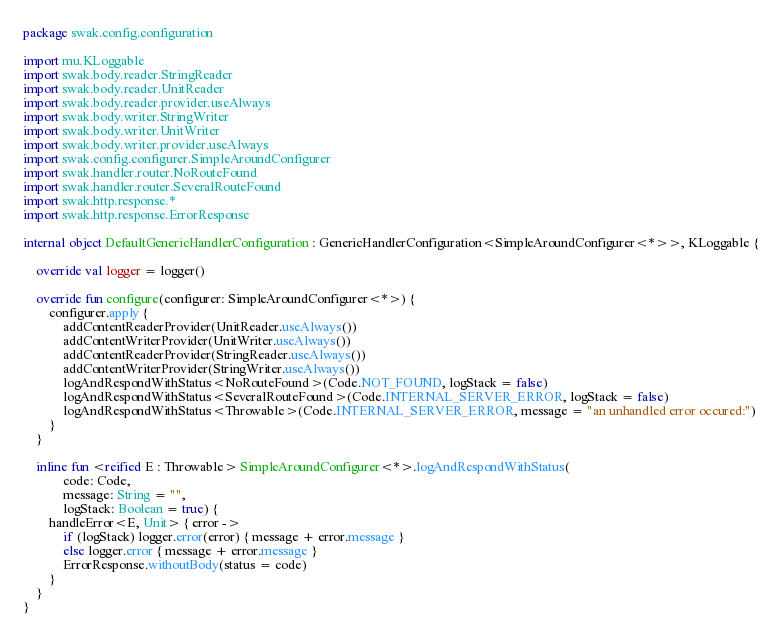<code> <loc_0><loc_0><loc_500><loc_500><_Kotlin_>package swak.config.configuration

import mu.KLoggable
import swak.body.reader.StringReader
import swak.body.reader.UnitReader
import swak.body.reader.provider.useAlways
import swak.body.writer.StringWriter
import swak.body.writer.UnitWriter
import swak.body.writer.provider.useAlways
import swak.config.configurer.SimpleAroundConfigurer
import swak.handler.router.NoRouteFound
import swak.handler.router.SeveralRouteFound
import swak.http.response.*
import swak.http.response.ErrorResponse

internal object DefaultGenericHandlerConfiguration : GenericHandlerConfiguration<SimpleAroundConfigurer<*>>, KLoggable {

    override val logger = logger()

    override fun configure(configurer: SimpleAroundConfigurer<*>) {
        configurer.apply {
            addContentReaderProvider(UnitReader.useAlways())
            addContentWriterProvider(UnitWriter.useAlways())
            addContentReaderProvider(StringReader.useAlways())
            addContentWriterProvider(StringWriter.useAlways())
            logAndRespondWithStatus<NoRouteFound>(Code.NOT_FOUND, logStack = false)
            logAndRespondWithStatus<SeveralRouteFound>(Code.INTERNAL_SERVER_ERROR, logStack = false)
            logAndRespondWithStatus<Throwable>(Code.INTERNAL_SERVER_ERROR, message = "an unhandled error occured:")
        }
    }

    inline fun <reified E : Throwable> SimpleAroundConfigurer<*>.logAndRespondWithStatus(
            code: Code,
            message: String = "",
            logStack: Boolean = true) {
        handleError<E, Unit> { error ->
            if (logStack) logger.error(error) { message + error.message }
            else logger.error { message + error.message }
            ErrorResponse.withoutBody(status = code)
        }
    }
}

</code> 